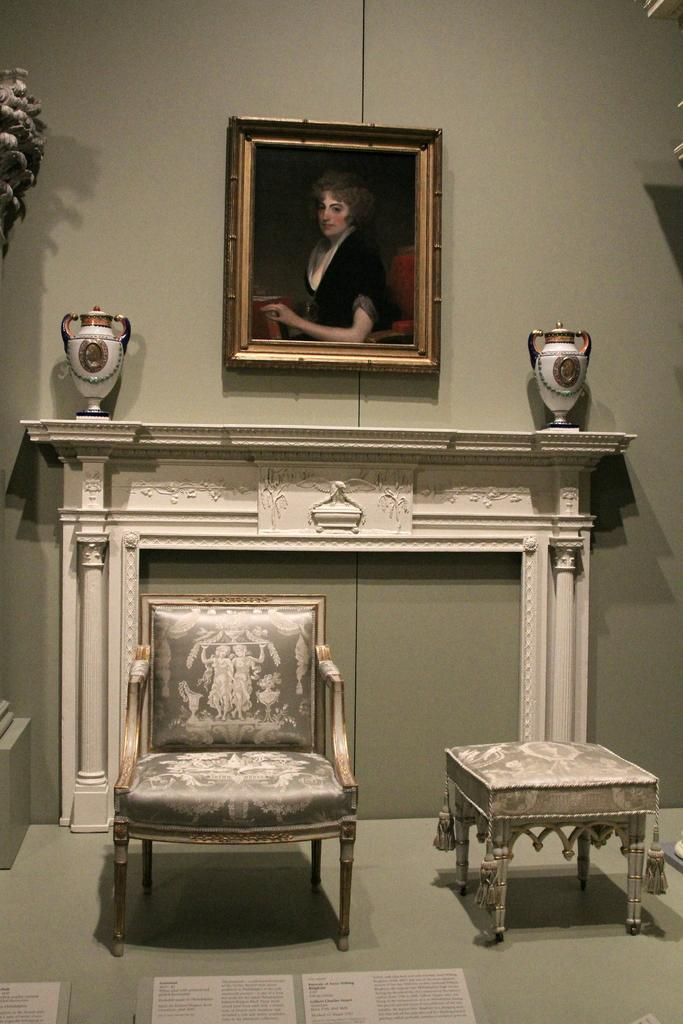What type of furniture is present in the room? There is a chair and a stool in the room. What can be seen on the wall in the room? There is a frame on the wall in the room. What type of plane can be seen flying in the room? There is no plane visible in the room; it is an indoor space with a chair, stool, and frame on the wall. 